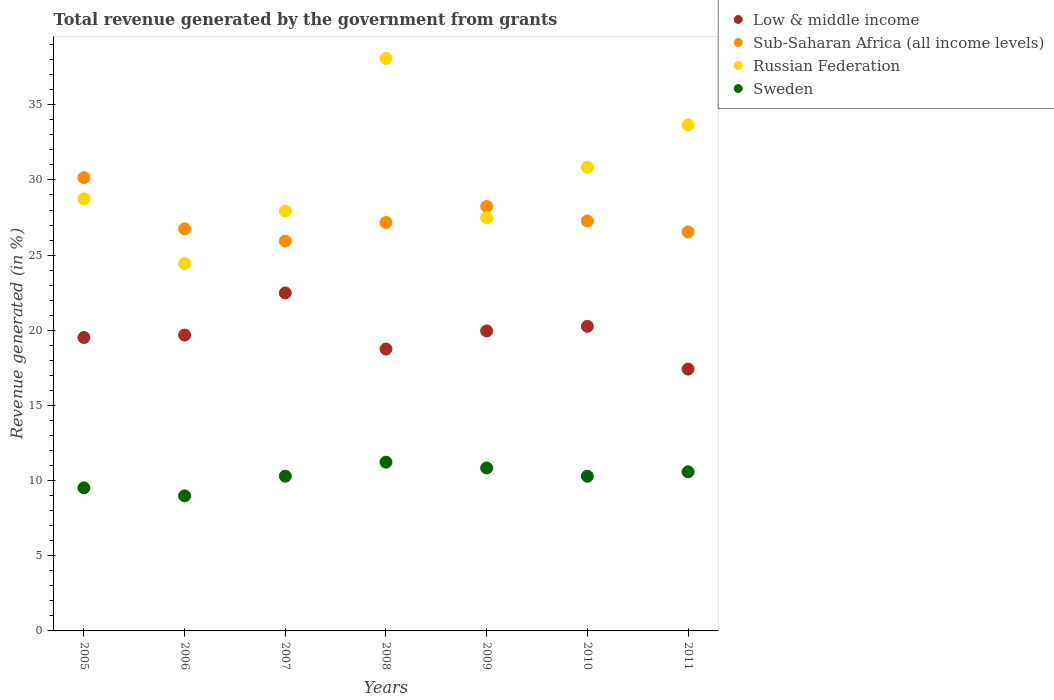How many different coloured dotlines are there?
Your answer should be compact. 4. Is the number of dotlines equal to the number of legend labels?
Your response must be concise. Yes. What is the total revenue generated in Sub-Saharan Africa (all income levels) in 2010?
Your answer should be compact. 27.27. Across all years, what is the maximum total revenue generated in Russian Federation?
Your answer should be compact. 38.08. Across all years, what is the minimum total revenue generated in Sweden?
Give a very brief answer. 8.99. In which year was the total revenue generated in Sweden maximum?
Offer a terse response. 2008. What is the total total revenue generated in Sweden in the graph?
Your answer should be very brief. 71.74. What is the difference between the total revenue generated in Sub-Saharan Africa (all income levels) in 2006 and that in 2007?
Ensure brevity in your answer.  0.81. What is the difference between the total revenue generated in Russian Federation in 2006 and the total revenue generated in Sub-Saharan Africa (all income levels) in 2005?
Provide a short and direct response. -5.71. What is the average total revenue generated in Sub-Saharan Africa (all income levels) per year?
Keep it short and to the point. 27.44. In the year 2009, what is the difference between the total revenue generated in Low & middle income and total revenue generated in Sub-Saharan Africa (all income levels)?
Offer a very short reply. -8.28. What is the ratio of the total revenue generated in Russian Federation in 2008 to that in 2010?
Offer a terse response. 1.23. What is the difference between the highest and the second highest total revenue generated in Sub-Saharan Africa (all income levels)?
Ensure brevity in your answer.  1.91. What is the difference between the highest and the lowest total revenue generated in Sweden?
Offer a terse response. 2.24. Is the total revenue generated in Sweden strictly greater than the total revenue generated in Low & middle income over the years?
Your response must be concise. No. How many dotlines are there?
Make the answer very short. 4. How many years are there in the graph?
Your answer should be very brief. 7. What is the difference between two consecutive major ticks on the Y-axis?
Your answer should be very brief. 5. Does the graph contain any zero values?
Ensure brevity in your answer.  No. How are the legend labels stacked?
Offer a very short reply. Vertical. What is the title of the graph?
Provide a short and direct response. Total revenue generated by the government from grants. What is the label or title of the X-axis?
Your response must be concise. Years. What is the label or title of the Y-axis?
Make the answer very short. Revenue generated (in %). What is the Revenue generated (in %) in Low & middle income in 2005?
Make the answer very short. 19.52. What is the Revenue generated (in %) of Sub-Saharan Africa (all income levels) in 2005?
Give a very brief answer. 30.15. What is the Revenue generated (in %) of Russian Federation in 2005?
Provide a short and direct response. 28.74. What is the Revenue generated (in %) in Sweden in 2005?
Ensure brevity in your answer.  9.52. What is the Revenue generated (in %) of Low & middle income in 2006?
Make the answer very short. 19.68. What is the Revenue generated (in %) in Sub-Saharan Africa (all income levels) in 2006?
Your answer should be very brief. 26.75. What is the Revenue generated (in %) of Russian Federation in 2006?
Give a very brief answer. 24.44. What is the Revenue generated (in %) in Sweden in 2006?
Provide a short and direct response. 8.99. What is the Revenue generated (in %) of Low & middle income in 2007?
Keep it short and to the point. 22.48. What is the Revenue generated (in %) in Sub-Saharan Africa (all income levels) in 2007?
Provide a short and direct response. 25.94. What is the Revenue generated (in %) in Russian Federation in 2007?
Your response must be concise. 27.93. What is the Revenue generated (in %) in Sweden in 2007?
Provide a short and direct response. 10.29. What is the Revenue generated (in %) in Low & middle income in 2008?
Ensure brevity in your answer.  18.75. What is the Revenue generated (in %) in Sub-Saharan Africa (all income levels) in 2008?
Your answer should be compact. 27.17. What is the Revenue generated (in %) in Russian Federation in 2008?
Offer a very short reply. 38.08. What is the Revenue generated (in %) in Sweden in 2008?
Provide a short and direct response. 11.23. What is the Revenue generated (in %) of Low & middle income in 2009?
Ensure brevity in your answer.  19.96. What is the Revenue generated (in %) in Sub-Saharan Africa (all income levels) in 2009?
Provide a succinct answer. 28.24. What is the Revenue generated (in %) of Russian Federation in 2009?
Ensure brevity in your answer.  27.48. What is the Revenue generated (in %) in Sweden in 2009?
Ensure brevity in your answer.  10.84. What is the Revenue generated (in %) in Low & middle income in 2010?
Your response must be concise. 20.26. What is the Revenue generated (in %) of Sub-Saharan Africa (all income levels) in 2010?
Provide a short and direct response. 27.27. What is the Revenue generated (in %) in Russian Federation in 2010?
Give a very brief answer. 30.84. What is the Revenue generated (in %) in Sweden in 2010?
Ensure brevity in your answer.  10.29. What is the Revenue generated (in %) in Low & middle income in 2011?
Your response must be concise. 17.42. What is the Revenue generated (in %) in Sub-Saharan Africa (all income levels) in 2011?
Give a very brief answer. 26.54. What is the Revenue generated (in %) in Russian Federation in 2011?
Offer a terse response. 33.66. What is the Revenue generated (in %) of Sweden in 2011?
Provide a short and direct response. 10.59. Across all years, what is the maximum Revenue generated (in %) in Low & middle income?
Offer a terse response. 22.48. Across all years, what is the maximum Revenue generated (in %) in Sub-Saharan Africa (all income levels)?
Provide a succinct answer. 30.15. Across all years, what is the maximum Revenue generated (in %) in Russian Federation?
Your answer should be very brief. 38.08. Across all years, what is the maximum Revenue generated (in %) in Sweden?
Offer a terse response. 11.23. Across all years, what is the minimum Revenue generated (in %) in Low & middle income?
Ensure brevity in your answer.  17.42. Across all years, what is the minimum Revenue generated (in %) of Sub-Saharan Africa (all income levels)?
Give a very brief answer. 25.94. Across all years, what is the minimum Revenue generated (in %) of Russian Federation?
Make the answer very short. 24.44. Across all years, what is the minimum Revenue generated (in %) in Sweden?
Offer a very short reply. 8.99. What is the total Revenue generated (in %) of Low & middle income in the graph?
Your response must be concise. 138.07. What is the total Revenue generated (in %) in Sub-Saharan Africa (all income levels) in the graph?
Provide a succinct answer. 192.06. What is the total Revenue generated (in %) in Russian Federation in the graph?
Offer a terse response. 211.19. What is the total Revenue generated (in %) of Sweden in the graph?
Make the answer very short. 71.74. What is the difference between the Revenue generated (in %) in Low & middle income in 2005 and that in 2006?
Your answer should be very brief. -0.16. What is the difference between the Revenue generated (in %) of Sub-Saharan Africa (all income levels) in 2005 and that in 2006?
Your answer should be very brief. 3.4. What is the difference between the Revenue generated (in %) in Russian Federation in 2005 and that in 2006?
Provide a succinct answer. 4.3. What is the difference between the Revenue generated (in %) in Sweden in 2005 and that in 2006?
Your response must be concise. 0.53. What is the difference between the Revenue generated (in %) in Low & middle income in 2005 and that in 2007?
Keep it short and to the point. -2.97. What is the difference between the Revenue generated (in %) of Sub-Saharan Africa (all income levels) in 2005 and that in 2007?
Your answer should be very brief. 4.22. What is the difference between the Revenue generated (in %) in Russian Federation in 2005 and that in 2007?
Ensure brevity in your answer.  0.82. What is the difference between the Revenue generated (in %) in Sweden in 2005 and that in 2007?
Provide a short and direct response. -0.78. What is the difference between the Revenue generated (in %) of Low & middle income in 2005 and that in 2008?
Ensure brevity in your answer.  0.77. What is the difference between the Revenue generated (in %) in Sub-Saharan Africa (all income levels) in 2005 and that in 2008?
Your answer should be compact. 2.98. What is the difference between the Revenue generated (in %) of Russian Federation in 2005 and that in 2008?
Offer a terse response. -9.34. What is the difference between the Revenue generated (in %) of Sweden in 2005 and that in 2008?
Provide a succinct answer. -1.71. What is the difference between the Revenue generated (in %) of Low & middle income in 2005 and that in 2009?
Offer a terse response. -0.44. What is the difference between the Revenue generated (in %) in Sub-Saharan Africa (all income levels) in 2005 and that in 2009?
Provide a succinct answer. 1.91. What is the difference between the Revenue generated (in %) in Russian Federation in 2005 and that in 2009?
Your response must be concise. 1.26. What is the difference between the Revenue generated (in %) in Sweden in 2005 and that in 2009?
Your response must be concise. -1.32. What is the difference between the Revenue generated (in %) in Low & middle income in 2005 and that in 2010?
Give a very brief answer. -0.74. What is the difference between the Revenue generated (in %) in Sub-Saharan Africa (all income levels) in 2005 and that in 2010?
Your response must be concise. 2.88. What is the difference between the Revenue generated (in %) of Russian Federation in 2005 and that in 2010?
Provide a short and direct response. -2.1. What is the difference between the Revenue generated (in %) of Sweden in 2005 and that in 2010?
Your answer should be very brief. -0.77. What is the difference between the Revenue generated (in %) in Low & middle income in 2005 and that in 2011?
Offer a terse response. 2.1. What is the difference between the Revenue generated (in %) in Sub-Saharan Africa (all income levels) in 2005 and that in 2011?
Your answer should be very brief. 3.61. What is the difference between the Revenue generated (in %) of Russian Federation in 2005 and that in 2011?
Make the answer very short. -4.92. What is the difference between the Revenue generated (in %) of Sweden in 2005 and that in 2011?
Give a very brief answer. -1.07. What is the difference between the Revenue generated (in %) in Low & middle income in 2006 and that in 2007?
Keep it short and to the point. -2.8. What is the difference between the Revenue generated (in %) of Sub-Saharan Africa (all income levels) in 2006 and that in 2007?
Provide a succinct answer. 0.81. What is the difference between the Revenue generated (in %) of Russian Federation in 2006 and that in 2007?
Make the answer very short. -3.49. What is the difference between the Revenue generated (in %) in Sweden in 2006 and that in 2007?
Your response must be concise. -1.31. What is the difference between the Revenue generated (in %) of Low & middle income in 2006 and that in 2008?
Offer a very short reply. 0.93. What is the difference between the Revenue generated (in %) in Sub-Saharan Africa (all income levels) in 2006 and that in 2008?
Your response must be concise. -0.42. What is the difference between the Revenue generated (in %) of Russian Federation in 2006 and that in 2008?
Offer a terse response. -13.64. What is the difference between the Revenue generated (in %) in Sweden in 2006 and that in 2008?
Ensure brevity in your answer.  -2.24. What is the difference between the Revenue generated (in %) in Low & middle income in 2006 and that in 2009?
Offer a very short reply. -0.28. What is the difference between the Revenue generated (in %) in Sub-Saharan Africa (all income levels) in 2006 and that in 2009?
Keep it short and to the point. -1.49. What is the difference between the Revenue generated (in %) of Russian Federation in 2006 and that in 2009?
Provide a succinct answer. -3.04. What is the difference between the Revenue generated (in %) in Sweden in 2006 and that in 2009?
Keep it short and to the point. -1.85. What is the difference between the Revenue generated (in %) in Low & middle income in 2006 and that in 2010?
Ensure brevity in your answer.  -0.58. What is the difference between the Revenue generated (in %) in Sub-Saharan Africa (all income levels) in 2006 and that in 2010?
Offer a very short reply. -0.52. What is the difference between the Revenue generated (in %) of Russian Federation in 2006 and that in 2010?
Your response must be concise. -6.4. What is the difference between the Revenue generated (in %) of Sweden in 2006 and that in 2010?
Ensure brevity in your answer.  -1.31. What is the difference between the Revenue generated (in %) of Low & middle income in 2006 and that in 2011?
Offer a very short reply. 2.26. What is the difference between the Revenue generated (in %) of Sub-Saharan Africa (all income levels) in 2006 and that in 2011?
Give a very brief answer. 0.2. What is the difference between the Revenue generated (in %) of Russian Federation in 2006 and that in 2011?
Ensure brevity in your answer.  -9.22. What is the difference between the Revenue generated (in %) of Sweden in 2006 and that in 2011?
Make the answer very short. -1.6. What is the difference between the Revenue generated (in %) in Low & middle income in 2007 and that in 2008?
Your response must be concise. 3.73. What is the difference between the Revenue generated (in %) of Sub-Saharan Africa (all income levels) in 2007 and that in 2008?
Ensure brevity in your answer.  -1.23. What is the difference between the Revenue generated (in %) in Russian Federation in 2007 and that in 2008?
Your response must be concise. -10.16. What is the difference between the Revenue generated (in %) of Sweden in 2007 and that in 2008?
Your answer should be very brief. -0.93. What is the difference between the Revenue generated (in %) in Low & middle income in 2007 and that in 2009?
Your response must be concise. 2.53. What is the difference between the Revenue generated (in %) in Sub-Saharan Africa (all income levels) in 2007 and that in 2009?
Offer a very short reply. -2.3. What is the difference between the Revenue generated (in %) in Russian Federation in 2007 and that in 2009?
Make the answer very short. 0.44. What is the difference between the Revenue generated (in %) in Sweden in 2007 and that in 2009?
Make the answer very short. -0.55. What is the difference between the Revenue generated (in %) in Low & middle income in 2007 and that in 2010?
Provide a succinct answer. 2.22. What is the difference between the Revenue generated (in %) of Sub-Saharan Africa (all income levels) in 2007 and that in 2010?
Your answer should be compact. -1.33. What is the difference between the Revenue generated (in %) in Russian Federation in 2007 and that in 2010?
Make the answer very short. -2.92. What is the difference between the Revenue generated (in %) of Sweden in 2007 and that in 2010?
Keep it short and to the point. 0. What is the difference between the Revenue generated (in %) of Low & middle income in 2007 and that in 2011?
Your answer should be very brief. 5.07. What is the difference between the Revenue generated (in %) of Sub-Saharan Africa (all income levels) in 2007 and that in 2011?
Your answer should be very brief. -0.61. What is the difference between the Revenue generated (in %) of Russian Federation in 2007 and that in 2011?
Keep it short and to the point. -5.73. What is the difference between the Revenue generated (in %) of Sweden in 2007 and that in 2011?
Give a very brief answer. -0.29. What is the difference between the Revenue generated (in %) in Low & middle income in 2008 and that in 2009?
Offer a very short reply. -1.2. What is the difference between the Revenue generated (in %) of Sub-Saharan Africa (all income levels) in 2008 and that in 2009?
Your answer should be very brief. -1.07. What is the difference between the Revenue generated (in %) of Russian Federation in 2008 and that in 2009?
Your response must be concise. 10.6. What is the difference between the Revenue generated (in %) in Sweden in 2008 and that in 2009?
Make the answer very short. 0.39. What is the difference between the Revenue generated (in %) in Low & middle income in 2008 and that in 2010?
Keep it short and to the point. -1.51. What is the difference between the Revenue generated (in %) of Sub-Saharan Africa (all income levels) in 2008 and that in 2010?
Offer a terse response. -0.1. What is the difference between the Revenue generated (in %) of Russian Federation in 2008 and that in 2010?
Your response must be concise. 7.24. What is the difference between the Revenue generated (in %) of Sweden in 2008 and that in 2010?
Your answer should be very brief. 0.94. What is the difference between the Revenue generated (in %) in Low & middle income in 2008 and that in 2011?
Your answer should be very brief. 1.33. What is the difference between the Revenue generated (in %) of Sub-Saharan Africa (all income levels) in 2008 and that in 2011?
Your answer should be compact. 0.62. What is the difference between the Revenue generated (in %) in Russian Federation in 2008 and that in 2011?
Your response must be concise. 4.42. What is the difference between the Revenue generated (in %) of Sweden in 2008 and that in 2011?
Give a very brief answer. 0.64. What is the difference between the Revenue generated (in %) in Low & middle income in 2009 and that in 2010?
Your answer should be very brief. -0.31. What is the difference between the Revenue generated (in %) in Sub-Saharan Africa (all income levels) in 2009 and that in 2010?
Your response must be concise. 0.97. What is the difference between the Revenue generated (in %) in Russian Federation in 2009 and that in 2010?
Your answer should be compact. -3.36. What is the difference between the Revenue generated (in %) of Sweden in 2009 and that in 2010?
Ensure brevity in your answer.  0.55. What is the difference between the Revenue generated (in %) in Low & middle income in 2009 and that in 2011?
Offer a terse response. 2.54. What is the difference between the Revenue generated (in %) in Sub-Saharan Africa (all income levels) in 2009 and that in 2011?
Ensure brevity in your answer.  1.69. What is the difference between the Revenue generated (in %) in Russian Federation in 2009 and that in 2011?
Offer a terse response. -6.18. What is the difference between the Revenue generated (in %) in Sweden in 2009 and that in 2011?
Keep it short and to the point. 0.26. What is the difference between the Revenue generated (in %) in Low & middle income in 2010 and that in 2011?
Offer a very short reply. 2.84. What is the difference between the Revenue generated (in %) in Sub-Saharan Africa (all income levels) in 2010 and that in 2011?
Provide a short and direct response. 0.72. What is the difference between the Revenue generated (in %) of Russian Federation in 2010 and that in 2011?
Provide a succinct answer. -2.82. What is the difference between the Revenue generated (in %) in Sweden in 2010 and that in 2011?
Give a very brief answer. -0.29. What is the difference between the Revenue generated (in %) of Low & middle income in 2005 and the Revenue generated (in %) of Sub-Saharan Africa (all income levels) in 2006?
Provide a short and direct response. -7.23. What is the difference between the Revenue generated (in %) of Low & middle income in 2005 and the Revenue generated (in %) of Russian Federation in 2006?
Your answer should be compact. -4.92. What is the difference between the Revenue generated (in %) in Low & middle income in 2005 and the Revenue generated (in %) in Sweden in 2006?
Offer a terse response. 10.53. What is the difference between the Revenue generated (in %) of Sub-Saharan Africa (all income levels) in 2005 and the Revenue generated (in %) of Russian Federation in 2006?
Provide a succinct answer. 5.71. What is the difference between the Revenue generated (in %) of Sub-Saharan Africa (all income levels) in 2005 and the Revenue generated (in %) of Sweden in 2006?
Offer a very short reply. 21.17. What is the difference between the Revenue generated (in %) of Russian Federation in 2005 and the Revenue generated (in %) of Sweden in 2006?
Give a very brief answer. 19.76. What is the difference between the Revenue generated (in %) in Low & middle income in 2005 and the Revenue generated (in %) in Sub-Saharan Africa (all income levels) in 2007?
Ensure brevity in your answer.  -6.42. What is the difference between the Revenue generated (in %) in Low & middle income in 2005 and the Revenue generated (in %) in Russian Federation in 2007?
Offer a terse response. -8.41. What is the difference between the Revenue generated (in %) in Low & middle income in 2005 and the Revenue generated (in %) in Sweden in 2007?
Offer a very short reply. 9.22. What is the difference between the Revenue generated (in %) of Sub-Saharan Africa (all income levels) in 2005 and the Revenue generated (in %) of Russian Federation in 2007?
Give a very brief answer. 2.22. What is the difference between the Revenue generated (in %) in Sub-Saharan Africa (all income levels) in 2005 and the Revenue generated (in %) in Sweden in 2007?
Keep it short and to the point. 19.86. What is the difference between the Revenue generated (in %) in Russian Federation in 2005 and the Revenue generated (in %) in Sweden in 2007?
Offer a terse response. 18.45. What is the difference between the Revenue generated (in %) in Low & middle income in 2005 and the Revenue generated (in %) in Sub-Saharan Africa (all income levels) in 2008?
Provide a short and direct response. -7.65. What is the difference between the Revenue generated (in %) of Low & middle income in 2005 and the Revenue generated (in %) of Russian Federation in 2008?
Provide a short and direct response. -18.57. What is the difference between the Revenue generated (in %) in Low & middle income in 2005 and the Revenue generated (in %) in Sweden in 2008?
Offer a very short reply. 8.29. What is the difference between the Revenue generated (in %) in Sub-Saharan Africa (all income levels) in 2005 and the Revenue generated (in %) in Russian Federation in 2008?
Keep it short and to the point. -7.93. What is the difference between the Revenue generated (in %) of Sub-Saharan Africa (all income levels) in 2005 and the Revenue generated (in %) of Sweden in 2008?
Your answer should be compact. 18.92. What is the difference between the Revenue generated (in %) in Russian Federation in 2005 and the Revenue generated (in %) in Sweden in 2008?
Offer a very short reply. 17.52. What is the difference between the Revenue generated (in %) of Low & middle income in 2005 and the Revenue generated (in %) of Sub-Saharan Africa (all income levels) in 2009?
Provide a short and direct response. -8.72. What is the difference between the Revenue generated (in %) of Low & middle income in 2005 and the Revenue generated (in %) of Russian Federation in 2009?
Keep it short and to the point. -7.97. What is the difference between the Revenue generated (in %) of Low & middle income in 2005 and the Revenue generated (in %) of Sweden in 2009?
Keep it short and to the point. 8.68. What is the difference between the Revenue generated (in %) in Sub-Saharan Africa (all income levels) in 2005 and the Revenue generated (in %) in Russian Federation in 2009?
Give a very brief answer. 2.67. What is the difference between the Revenue generated (in %) in Sub-Saharan Africa (all income levels) in 2005 and the Revenue generated (in %) in Sweden in 2009?
Make the answer very short. 19.31. What is the difference between the Revenue generated (in %) in Russian Federation in 2005 and the Revenue generated (in %) in Sweden in 2009?
Make the answer very short. 17.9. What is the difference between the Revenue generated (in %) in Low & middle income in 2005 and the Revenue generated (in %) in Sub-Saharan Africa (all income levels) in 2010?
Provide a short and direct response. -7.75. What is the difference between the Revenue generated (in %) in Low & middle income in 2005 and the Revenue generated (in %) in Russian Federation in 2010?
Give a very brief answer. -11.33. What is the difference between the Revenue generated (in %) of Low & middle income in 2005 and the Revenue generated (in %) of Sweden in 2010?
Provide a short and direct response. 9.23. What is the difference between the Revenue generated (in %) in Sub-Saharan Africa (all income levels) in 2005 and the Revenue generated (in %) in Russian Federation in 2010?
Your answer should be very brief. -0.69. What is the difference between the Revenue generated (in %) of Sub-Saharan Africa (all income levels) in 2005 and the Revenue generated (in %) of Sweden in 2010?
Keep it short and to the point. 19.86. What is the difference between the Revenue generated (in %) in Russian Federation in 2005 and the Revenue generated (in %) in Sweden in 2010?
Your response must be concise. 18.45. What is the difference between the Revenue generated (in %) in Low & middle income in 2005 and the Revenue generated (in %) in Sub-Saharan Africa (all income levels) in 2011?
Give a very brief answer. -7.03. What is the difference between the Revenue generated (in %) in Low & middle income in 2005 and the Revenue generated (in %) in Russian Federation in 2011?
Your answer should be compact. -14.14. What is the difference between the Revenue generated (in %) in Low & middle income in 2005 and the Revenue generated (in %) in Sweden in 2011?
Your answer should be very brief. 8.93. What is the difference between the Revenue generated (in %) of Sub-Saharan Africa (all income levels) in 2005 and the Revenue generated (in %) of Russian Federation in 2011?
Give a very brief answer. -3.51. What is the difference between the Revenue generated (in %) in Sub-Saharan Africa (all income levels) in 2005 and the Revenue generated (in %) in Sweden in 2011?
Your response must be concise. 19.57. What is the difference between the Revenue generated (in %) in Russian Federation in 2005 and the Revenue generated (in %) in Sweden in 2011?
Offer a very short reply. 18.16. What is the difference between the Revenue generated (in %) of Low & middle income in 2006 and the Revenue generated (in %) of Sub-Saharan Africa (all income levels) in 2007?
Offer a terse response. -6.25. What is the difference between the Revenue generated (in %) in Low & middle income in 2006 and the Revenue generated (in %) in Russian Federation in 2007?
Make the answer very short. -8.25. What is the difference between the Revenue generated (in %) of Low & middle income in 2006 and the Revenue generated (in %) of Sweden in 2007?
Your answer should be compact. 9.39. What is the difference between the Revenue generated (in %) in Sub-Saharan Africa (all income levels) in 2006 and the Revenue generated (in %) in Russian Federation in 2007?
Your response must be concise. -1.18. What is the difference between the Revenue generated (in %) in Sub-Saharan Africa (all income levels) in 2006 and the Revenue generated (in %) in Sweden in 2007?
Keep it short and to the point. 16.45. What is the difference between the Revenue generated (in %) in Russian Federation in 2006 and the Revenue generated (in %) in Sweden in 2007?
Provide a succinct answer. 14.15. What is the difference between the Revenue generated (in %) in Low & middle income in 2006 and the Revenue generated (in %) in Sub-Saharan Africa (all income levels) in 2008?
Ensure brevity in your answer.  -7.49. What is the difference between the Revenue generated (in %) in Low & middle income in 2006 and the Revenue generated (in %) in Russian Federation in 2008?
Ensure brevity in your answer.  -18.4. What is the difference between the Revenue generated (in %) in Low & middle income in 2006 and the Revenue generated (in %) in Sweden in 2008?
Keep it short and to the point. 8.45. What is the difference between the Revenue generated (in %) in Sub-Saharan Africa (all income levels) in 2006 and the Revenue generated (in %) in Russian Federation in 2008?
Your answer should be very brief. -11.34. What is the difference between the Revenue generated (in %) in Sub-Saharan Africa (all income levels) in 2006 and the Revenue generated (in %) in Sweden in 2008?
Your response must be concise. 15.52. What is the difference between the Revenue generated (in %) in Russian Federation in 2006 and the Revenue generated (in %) in Sweden in 2008?
Offer a very short reply. 13.21. What is the difference between the Revenue generated (in %) in Low & middle income in 2006 and the Revenue generated (in %) in Sub-Saharan Africa (all income levels) in 2009?
Offer a very short reply. -8.56. What is the difference between the Revenue generated (in %) of Low & middle income in 2006 and the Revenue generated (in %) of Russian Federation in 2009?
Give a very brief answer. -7.8. What is the difference between the Revenue generated (in %) of Low & middle income in 2006 and the Revenue generated (in %) of Sweden in 2009?
Provide a short and direct response. 8.84. What is the difference between the Revenue generated (in %) of Sub-Saharan Africa (all income levels) in 2006 and the Revenue generated (in %) of Russian Federation in 2009?
Your answer should be compact. -0.74. What is the difference between the Revenue generated (in %) in Sub-Saharan Africa (all income levels) in 2006 and the Revenue generated (in %) in Sweden in 2009?
Provide a succinct answer. 15.91. What is the difference between the Revenue generated (in %) in Russian Federation in 2006 and the Revenue generated (in %) in Sweden in 2009?
Your answer should be compact. 13.6. What is the difference between the Revenue generated (in %) of Low & middle income in 2006 and the Revenue generated (in %) of Sub-Saharan Africa (all income levels) in 2010?
Ensure brevity in your answer.  -7.59. What is the difference between the Revenue generated (in %) in Low & middle income in 2006 and the Revenue generated (in %) in Russian Federation in 2010?
Your answer should be compact. -11.16. What is the difference between the Revenue generated (in %) of Low & middle income in 2006 and the Revenue generated (in %) of Sweden in 2010?
Make the answer very short. 9.39. What is the difference between the Revenue generated (in %) of Sub-Saharan Africa (all income levels) in 2006 and the Revenue generated (in %) of Russian Federation in 2010?
Ensure brevity in your answer.  -4.1. What is the difference between the Revenue generated (in %) of Sub-Saharan Africa (all income levels) in 2006 and the Revenue generated (in %) of Sweden in 2010?
Provide a short and direct response. 16.46. What is the difference between the Revenue generated (in %) of Russian Federation in 2006 and the Revenue generated (in %) of Sweden in 2010?
Your answer should be compact. 14.15. What is the difference between the Revenue generated (in %) in Low & middle income in 2006 and the Revenue generated (in %) in Sub-Saharan Africa (all income levels) in 2011?
Give a very brief answer. -6.86. What is the difference between the Revenue generated (in %) of Low & middle income in 2006 and the Revenue generated (in %) of Russian Federation in 2011?
Your answer should be very brief. -13.98. What is the difference between the Revenue generated (in %) in Low & middle income in 2006 and the Revenue generated (in %) in Sweden in 2011?
Make the answer very short. 9.1. What is the difference between the Revenue generated (in %) of Sub-Saharan Africa (all income levels) in 2006 and the Revenue generated (in %) of Russian Federation in 2011?
Provide a short and direct response. -6.92. What is the difference between the Revenue generated (in %) of Sub-Saharan Africa (all income levels) in 2006 and the Revenue generated (in %) of Sweden in 2011?
Provide a short and direct response. 16.16. What is the difference between the Revenue generated (in %) of Russian Federation in 2006 and the Revenue generated (in %) of Sweden in 2011?
Provide a short and direct response. 13.86. What is the difference between the Revenue generated (in %) in Low & middle income in 2007 and the Revenue generated (in %) in Sub-Saharan Africa (all income levels) in 2008?
Offer a very short reply. -4.68. What is the difference between the Revenue generated (in %) of Low & middle income in 2007 and the Revenue generated (in %) of Russian Federation in 2008?
Your response must be concise. -15.6. What is the difference between the Revenue generated (in %) of Low & middle income in 2007 and the Revenue generated (in %) of Sweden in 2008?
Your response must be concise. 11.26. What is the difference between the Revenue generated (in %) in Sub-Saharan Africa (all income levels) in 2007 and the Revenue generated (in %) in Russian Federation in 2008?
Provide a short and direct response. -12.15. What is the difference between the Revenue generated (in %) of Sub-Saharan Africa (all income levels) in 2007 and the Revenue generated (in %) of Sweden in 2008?
Your answer should be compact. 14.71. What is the difference between the Revenue generated (in %) in Russian Federation in 2007 and the Revenue generated (in %) in Sweden in 2008?
Keep it short and to the point. 16.7. What is the difference between the Revenue generated (in %) of Low & middle income in 2007 and the Revenue generated (in %) of Sub-Saharan Africa (all income levels) in 2009?
Keep it short and to the point. -5.75. What is the difference between the Revenue generated (in %) of Low & middle income in 2007 and the Revenue generated (in %) of Russian Federation in 2009?
Provide a short and direct response. -5. What is the difference between the Revenue generated (in %) in Low & middle income in 2007 and the Revenue generated (in %) in Sweden in 2009?
Provide a succinct answer. 11.64. What is the difference between the Revenue generated (in %) in Sub-Saharan Africa (all income levels) in 2007 and the Revenue generated (in %) in Russian Federation in 2009?
Offer a terse response. -1.55. What is the difference between the Revenue generated (in %) of Sub-Saharan Africa (all income levels) in 2007 and the Revenue generated (in %) of Sweden in 2009?
Ensure brevity in your answer.  15.1. What is the difference between the Revenue generated (in %) in Russian Federation in 2007 and the Revenue generated (in %) in Sweden in 2009?
Provide a short and direct response. 17.09. What is the difference between the Revenue generated (in %) in Low & middle income in 2007 and the Revenue generated (in %) in Sub-Saharan Africa (all income levels) in 2010?
Provide a short and direct response. -4.78. What is the difference between the Revenue generated (in %) of Low & middle income in 2007 and the Revenue generated (in %) of Russian Federation in 2010?
Provide a short and direct response. -8.36. What is the difference between the Revenue generated (in %) of Low & middle income in 2007 and the Revenue generated (in %) of Sweden in 2010?
Your answer should be compact. 12.19. What is the difference between the Revenue generated (in %) in Sub-Saharan Africa (all income levels) in 2007 and the Revenue generated (in %) in Russian Federation in 2010?
Provide a short and direct response. -4.91. What is the difference between the Revenue generated (in %) in Sub-Saharan Africa (all income levels) in 2007 and the Revenue generated (in %) in Sweden in 2010?
Offer a terse response. 15.64. What is the difference between the Revenue generated (in %) of Russian Federation in 2007 and the Revenue generated (in %) of Sweden in 2010?
Your response must be concise. 17.64. What is the difference between the Revenue generated (in %) of Low & middle income in 2007 and the Revenue generated (in %) of Sub-Saharan Africa (all income levels) in 2011?
Make the answer very short. -4.06. What is the difference between the Revenue generated (in %) of Low & middle income in 2007 and the Revenue generated (in %) of Russian Federation in 2011?
Keep it short and to the point. -11.18. What is the difference between the Revenue generated (in %) of Low & middle income in 2007 and the Revenue generated (in %) of Sweden in 2011?
Your response must be concise. 11.9. What is the difference between the Revenue generated (in %) in Sub-Saharan Africa (all income levels) in 2007 and the Revenue generated (in %) in Russian Federation in 2011?
Offer a terse response. -7.73. What is the difference between the Revenue generated (in %) in Sub-Saharan Africa (all income levels) in 2007 and the Revenue generated (in %) in Sweden in 2011?
Your answer should be compact. 15.35. What is the difference between the Revenue generated (in %) of Russian Federation in 2007 and the Revenue generated (in %) of Sweden in 2011?
Your answer should be very brief. 17.34. What is the difference between the Revenue generated (in %) in Low & middle income in 2008 and the Revenue generated (in %) in Sub-Saharan Africa (all income levels) in 2009?
Offer a very short reply. -9.49. What is the difference between the Revenue generated (in %) of Low & middle income in 2008 and the Revenue generated (in %) of Russian Federation in 2009?
Your answer should be compact. -8.73. What is the difference between the Revenue generated (in %) of Low & middle income in 2008 and the Revenue generated (in %) of Sweden in 2009?
Provide a succinct answer. 7.91. What is the difference between the Revenue generated (in %) of Sub-Saharan Africa (all income levels) in 2008 and the Revenue generated (in %) of Russian Federation in 2009?
Ensure brevity in your answer.  -0.32. What is the difference between the Revenue generated (in %) in Sub-Saharan Africa (all income levels) in 2008 and the Revenue generated (in %) in Sweden in 2009?
Your answer should be very brief. 16.33. What is the difference between the Revenue generated (in %) in Russian Federation in 2008 and the Revenue generated (in %) in Sweden in 2009?
Keep it short and to the point. 27.24. What is the difference between the Revenue generated (in %) of Low & middle income in 2008 and the Revenue generated (in %) of Sub-Saharan Africa (all income levels) in 2010?
Make the answer very short. -8.52. What is the difference between the Revenue generated (in %) in Low & middle income in 2008 and the Revenue generated (in %) in Russian Federation in 2010?
Offer a terse response. -12.09. What is the difference between the Revenue generated (in %) of Low & middle income in 2008 and the Revenue generated (in %) of Sweden in 2010?
Offer a very short reply. 8.46. What is the difference between the Revenue generated (in %) in Sub-Saharan Africa (all income levels) in 2008 and the Revenue generated (in %) in Russian Federation in 2010?
Provide a short and direct response. -3.68. What is the difference between the Revenue generated (in %) in Sub-Saharan Africa (all income levels) in 2008 and the Revenue generated (in %) in Sweden in 2010?
Keep it short and to the point. 16.88. What is the difference between the Revenue generated (in %) in Russian Federation in 2008 and the Revenue generated (in %) in Sweden in 2010?
Give a very brief answer. 27.79. What is the difference between the Revenue generated (in %) in Low & middle income in 2008 and the Revenue generated (in %) in Sub-Saharan Africa (all income levels) in 2011?
Provide a short and direct response. -7.79. What is the difference between the Revenue generated (in %) in Low & middle income in 2008 and the Revenue generated (in %) in Russian Federation in 2011?
Your response must be concise. -14.91. What is the difference between the Revenue generated (in %) of Low & middle income in 2008 and the Revenue generated (in %) of Sweden in 2011?
Your answer should be compact. 8.17. What is the difference between the Revenue generated (in %) of Sub-Saharan Africa (all income levels) in 2008 and the Revenue generated (in %) of Russian Federation in 2011?
Make the answer very short. -6.49. What is the difference between the Revenue generated (in %) in Sub-Saharan Africa (all income levels) in 2008 and the Revenue generated (in %) in Sweden in 2011?
Your answer should be compact. 16.58. What is the difference between the Revenue generated (in %) of Russian Federation in 2008 and the Revenue generated (in %) of Sweden in 2011?
Offer a very short reply. 27.5. What is the difference between the Revenue generated (in %) in Low & middle income in 2009 and the Revenue generated (in %) in Sub-Saharan Africa (all income levels) in 2010?
Your response must be concise. -7.31. What is the difference between the Revenue generated (in %) in Low & middle income in 2009 and the Revenue generated (in %) in Russian Federation in 2010?
Give a very brief answer. -10.89. What is the difference between the Revenue generated (in %) in Low & middle income in 2009 and the Revenue generated (in %) in Sweden in 2010?
Your response must be concise. 9.67. What is the difference between the Revenue generated (in %) of Sub-Saharan Africa (all income levels) in 2009 and the Revenue generated (in %) of Russian Federation in 2010?
Give a very brief answer. -2.61. What is the difference between the Revenue generated (in %) in Sub-Saharan Africa (all income levels) in 2009 and the Revenue generated (in %) in Sweden in 2010?
Your answer should be very brief. 17.95. What is the difference between the Revenue generated (in %) of Russian Federation in 2009 and the Revenue generated (in %) of Sweden in 2010?
Provide a short and direct response. 17.19. What is the difference between the Revenue generated (in %) of Low & middle income in 2009 and the Revenue generated (in %) of Sub-Saharan Africa (all income levels) in 2011?
Ensure brevity in your answer.  -6.59. What is the difference between the Revenue generated (in %) of Low & middle income in 2009 and the Revenue generated (in %) of Russian Federation in 2011?
Make the answer very short. -13.71. What is the difference between the Revenue generated (in %) of Low & middle income in 2009 and the Revenue generated (in %) of Sweden in 2011?
Offer a terse response. 9.37. What is the difference between the Revenue generated (in %) of Sub-Saharan Africa (all income levels) in 2009 and the Revenue generated (in %) of Russian Federation in 2011?
Offer a terse response. -5.42. What is the difference between the Revenue generated (in %) of Sub-Saharan Africa (all income levels) in 2009 and the Revenue generated (in %) of Sweden in 2011?
Your answer should be very brief. 17.65. What is the difference between the Revenue generated (in %) of Russian Federation in 2009 and the Revenue generated (in %) of Sweden in 2011?
Your answer should be compact. 16.9. What is the difference between the Revenue generated (in %) in Low & middle income in 2010 and the Revenue generated (in %) in Sub-Saharan Africa (all income levels) in 2011?
Ensure brevity in your answer.  -6.28. What is the difference between the Revenue generated (in %) of Low & middle income in 2010 and the Revenue generated (in %) of Russian Federation in 2011?
Provide a succinct answer. -13.4. What is the difference between the Revenue generated (in %) in Low & middle income in 2010 and the Revenue generated (in %) in Sweden in 2011?
Offer a terse response. 9.68. What is the difference between the Revenue generated (in %) in Sub-Saharan Africa (all income levels) in 2010 and the Revenue generated (in %) in Russian Federation in 2011?
Give a very brief answer. -6.39. What is the difference between the Revenue generated (in %) of Sub-Saharan Africa (all income levels) in 2010 and the Revenue generated (in %) of Sweden in 2011?
Offer a very short reply. 16.68. What is the difference between the Revenue generated (in %) of Russian Federation in 2010 and the Revenue generated (in %) of Sweden in 2011?
Make the answer very short. 20.26. What is the average Revenue generated (in %) in Low & middle income per year?
Keep it short and to the point. 19.72. What is the average Revenue generated (in %) in Sub-Saharan Africa (all income levels) per year?
Offer a terse response. 27.44. What is the average Revenue generated (in %) in Russian Federation per year?
Provide a succinct answer. 30.17. What is the average Revenue generated (in %) of Sweden per year?
Offer a very short reply. 10.25. In the year 2005, what is the difference between the Revenue generated (in %) in Low & middle income and Revenue generated (in %) in Sub-Saharan Africa (all income levels)?
Offer a terse response. -10.63. In the year 2005, what is the difference between the Revenue generated (in %) in Low & middle income and Revenue generated (in %) in Russian Federation?
Your response must be concise. -9.23. In the year 2005, what is the difference between the Revenue generated (in %) of Low & middle income and Revenue generated (in %) of Sweden?
Ensure brevity in your answer.  10. In the year 2005, what is the difference between the Revenue generated (in %) in Sub-Saharan Africa (all income levels) and Revenue generated (in %) in Russian Federation?
Provide a short and direct response. 1.41. In the year 2005, what is the difference between the Revenue generated (in %) of Sub-Saharan Africa (all income levels) and Revenue generated (in %) of Sweden?
Keep it short and to the point. 20.63. In the year 2005, what is the difference between the Revenue generated (in %) of Russian Federation and Revenue generated (in %) of Sweden?
Provide a succinct answer. 19.23. In the year 2006, what is the difference between the Revenue generated (in %) in Low & middle income and Revenue generated (in %) in Sub-Saharan Africa (all income levels)?
Your answer should be very brief. -7.07. In the year 2006, what is the difference between the Revenue generated (in %) of Low & middle income and Revenue generated (in %) of Russian Federation?
Provide a short and direct response. -4.76. In the year 2006, what is the difference between the Revenue generated (in %) in Low & middle income and Revenue generated (in %) in Sweden?
Provide a succinct answer. 10.69. In the year 2006, what is the difference between the Revenue generated (in %) of Sub-Saharan Africa (all income levels) and Revenue generated (in %) of Russian Federation?
Make the answer very short. 2.31. In the year 2006, what is the difference between the Revenue generated (in %) of Sub-Saharan Africa (all income levels) and Revenue generated (in %) of Sweden?
Give a very brief answer. 17.76. In the year 2006, what is the difference between the Revenue generated (in %) in Russian Federation and Revenue generated (in %) in Sweden?
Make the answer very short. 15.45. In the year 2007, what is the difference between the Revenue generated (in %) in Low & middle income and Revenue generated (in %) in Sub-Saharan Africa (all income levels)?
Make the answer very short. -3.45. In the year 2007, what is the difference between the Revenue generated (in %) of Low & middle income and Revenue generated (in %) of Russian Federation?
Your answer should be compact. -5.44. In the year 2007, what is the difference between the Revenue generated (in %) in Low & middle income and Revenue generated (in %) in Sweden?
Make the answer very short. 12.19. In the year 2007, what is the difference between the Revenue generated (in %) of Sub-Saharan Africa (all income levels) and Revenue generated (in %) of Russian Federation?
Ensure brevity in your answer.  -1.99. In the year 2007, what is the difference between the Revenue generated (in %) in Sub-Saharan Africa (all income levels) and Revenue generated (in %) in Sweden?
Ensure brevity in your answer.  15.64. In the year 2007, what is the difference between the Revenue generated (in %) in Russian Federation and Revenue generated (in %) in Sweden?
Offer a terse response. 17.63. In the year 2008, what is the difference between the Revenue generated (in %) of Low & middle income and Revenue generated (in %) of Sub-Saharan Africa (all income levels)?
Give a very brief answer. -8.42. In the year 2008, what is the difference between the Revenue generated (in %) of Low & middle income and Revenue generated (in %) of Russian Federation?
Give a very brief answer. -19.33. In the year 2008, what is the difference between the Revenue generated (in %) of Low & middle income and Revenue generated (in %) of Sweden?
Your response must be concise. 7.52. In the year 2008, what is the difference between the Revenue generated (in %) of Sub-Saharan Africa (all income levels) and Revenue generated (in %) of Russian Federation?
Your response must be concise. -10.91. In the year 2008, what is the difference between the Revenue generated (in %) in Sub-Saharan Africa (all income levels) and Revenue generated (in %) in Sweden?
Your answer should be compact. 15.94. In the year 2008, what is the difference between the Revenue generated (in %) in Russian Federation and Revenue generated (in %) in Sweden?
Ensure brevity in your answer.  26.86. In the year 2009, what is the difference between the Revenue generated (in %) in Low & middle income and Revenue generated (in %) in Sub-Saharan Africa (all income levels)?
Provide a succinct answer. -8.28. In the year 2009, what is the difference between the Revenue generated (in %) in Low & middle income and Revenue generated (in %) in Russian Federation?
Your response must be concise. -7.53. In the year 2009, what is the difference between the Revenue generated (in %) of Low & middle income and Revenue generated (in %) of Sweden?
Ensure brevity in your answer.  9.12. In the year 2009, what is the difference between the Revenue generated (in %) in Sub-Saharan Africa (all income levels) and Revenue generated (in %) in Russian Federation?
Your answer should be compact. 0.75. In the year 2009, what is the difference between the Revenue generated (in %) of Sub-Saharan Africa (all income levels) and Revenue generated (in %) of Sweden?
Make the answer very short. 17.4. In the year 2009, what is the difference between the Revenue generated (in %) in Russian Federation and Revenue generated (in %) in Sweden?
Provide a short and direct response. 16.64. In the year 2010, what is the difference between the Revenue generated (in %) of Low & middle income and Revenue generated (in %) of Sub-Saharan Africa (all income levels)?
Your answer should be compact. -7.01. In the year 2010, what is the difference between the Revenue generated (in %) in Low & middle income and Revenue generated (in %) in Russian Federation?
Give a very brief answer. -10.58. In the year 2010, what is the difference between the Revenue generated (in %) in Low & middle income and Revenue generated (in %) in Sweden?
Make the answer very short. 9.97. In the year 2010, what is the difference between the Revenue generated (in %) of Sub-Saharan Africa (all income levels) and Revenue generated (in %) of Russian Federation?
Keep it short and to the point. -3.58. In the year 2010, what is the difference between the Revenue generated (in %) of Sub-Saharan Africa (all income levels) and Revenue generated (in %) of Sweden?
Offer a terse response. 16.98. In the year 2010, what is the difference between the Revenue generated (in %) of Russian Federation and Revenue generated (in %) of Sweden?
Make the answer very short. 20.55. In the year 2011, what is the difference between the Revenue generated (in %) in Low & middle income and Revenue generated (in %) in Sub-Saharan Africa (all income levels)?
Provide a short and direct response. -9.13. In the year 2011, what is the difference between the Revenue generated (in %) in Low & middle income and Revenue generated (in %) in Russian Federation?
Ensure brevity in your answer.  -16.25. In the year 2011, what is the difference between the Revenue generated (in %) in Low & middle income and Revenue generated (in %) in Sweden?
Make the answer very short. 6.83. In the year 2011, what is the difference between the Revenue generated (in %) in Sub-Saharan Africa (all income levels) and Revenue generated (in %) in Russian Federation?
Keep it short and to the point. -7.12. In the year 2011, what is the difference between the Revenue generated (in %) of Sub-Saharan Africa (all income levels) and Revenue generated (in %) of Sweden?
Offer a terse response. 15.96. In the year 2011, what is the difference between the Revenue generated (in %) of Russian Federation and Revenue generated (in %) of Sweden?
Offer a very short reply. 23.08. What is the ratio of the Revenue generated (in %) of Sub-Saharan Africa (all income levels) in 2005 to that in 2006?
Offer a very short reply. 1.13. What is the ratio of the Revenue generated (in %) of Russian Federation in 2005 to that in 2006?
Your answer should be compact. 1.18. What is the ratio of the Revenue generated (in %) of Sweden in 2005 to that in 2006?
Keep it short and to the point. 1.06. What is the ratio of the Revenue generated (in %) of Low & middle income in 2005 to that in 2007?
Ensure brevity in your answer.  0.87. What is the ratio of the Revenue generated (in %) in Sub-Saharan Africa (all income levels) in 2005 to that in 2007?
Provide a short and direct response. 1.16. What is the ratio of the Revenue generated (in %) in Russian Federation in 2005 to that in 2007?
Your answer should be compact. 1.03. What is the ratio of the Revenue generated (in %) in Sweden in 2005 to that in 2007?
Make the answer very short. 0.92. What is the ratio of the Revenue generated (in %) of Low & middle income in 2005 to that in 2008?
Keep it short and to the point. 1.04. What is the ratio of the Revenue generated (in %) in Sub-Saharan Africa (all income levels) in 2005 to that in 2008?
Ensure brevity in your answer.  1.11. What is the ratio of the Revenue generated (in %) of Russian Federation in 2005 to that in 2008?
Provide a short and direct response. 0.75. What is the ratio of the Revenue generated (in %) of Sweden in 2005 to that in 2008?
Ensure brevity in your answer.  0.85. What is the ratio of the Revenue generated (in %) in Low & middle income in 2005 to that in 2009?
Provide a succinct answer. 0.98. What is the ratio of the Revenue generated (in %) of Sub-Saharan Africa (all income levels) in 2005 to that in 2009?
Offer a terse response. 1.07. What is the ratio of the Revenue generated (in %) of Russian Federation in 2005 to that in 2009?
Provide a short and direct response. 1.05. What is the ratio of the Revenue generated (in %) of Sweden in 2005 to that in 2009?
Keep it short and to the point. 0.88. What is the ratio of the Revenue generated (in %) of Low & middle income in 2005 to that in 2010?
Your response must be concise. 0.96. What is the ratio of the Revenue generated (in %) in Sub-Saharan Africa (all income levels) in 2005 to that in 2010?
Provide a short and direct response. 1.11. What is the ratio of the Revenue generated (in %) of Russian Federation in 2005 to that in 2010?
Your answer should be very brief. 0.93. What is the ratio of the Revenue generated (in %) in Sweden in 2005 to that in 2010?
Offer a terse response. 0.92. What is the ratio of the Revenue generated (in %) in Low & middle income in 2005 to that in 2011?
Provide a succinct answer. 1.12. What is the ratio of the Revenue generated (in %) of Sub-Saharan Africa (all income levels) in 2005 to that in 2011?
Your answer should be very brief. 1.14. What is the ratio of the Revenue generated (in %) of Russian Federation in 2005 to that in 2011?
Make the answer very short. 0.85. What is the ratio of the Revenue generated (in %) of Sweden in 2005 to that in 2011?
Keep it short and to the point. 0.9. What is the ratio of the Revenue generated (in %) of Low & middle income in 2006 to that in 2007?
Offer a very short reply. 0.88. What is the ratio of the Revenue generated (in %) in Sub-Saharan Africa (all income levels) in 2006 to that in 2007?
Your response must be concise. 1.03. What is the ratio of the Revenue generated (in %) of Russian Federation in 2006 to that in 2007?
Offer a very short reply. 0.88. What is the ratio of the Revenue generated (in %) of Sweden in 2006 to that in 2007?
Offer a terse response. 0.87. What is the ratio of the Revenue generated (in %) in Low & middle income in 2006 to that in 2008?
Ensure brevity in your answer.  1.05. What is the ratio of the Revenue generated (in %) in Sub-Saharan Africa (all income levels) in 2006 to that in 2008?
Keep it short and to the point. 0.98. What is the ratio of the Revenue generated (in %) in Russian Federation in 2006 to that in 2008?
Give a very brief answer. 0.64. What is the ratio of the Revenue generated (in %) of Sweden in 2006 to that in 2008?
Provide a short and direct response. 0.8. What is the ratio of the Revenue generated (in %) in Low & middle income in 2006 to that in 2009?
Your answer should be compact. 0.99. What is the ratio of the Revenue generated (in %) in Sub-Saharan Africa (all income levels) in 2006 to that in 2009?
Provide a short and direct response. 0.95. What is the ratio of the Revenue generated (in %) in Russian Federation in 2006 to that in 2009?
Keep it short and to the point. 0.89. What is the ratio of the Revenue generated (in %) in Sweden in 2006 to that in 2009?
Your answer should be very brief. 0.83. What is the ratio of the Revenue generated (in %) of Low & middle income in 2006 to that in 2010?
Your response must be concise. 0.97. What is the ratio of the Revenue generated (in %) of Sub-Saharan Africa (all income levels) in 2006 to that in 2010?
Give a very brief answer. 0.98. What is the ratio of the Revenue generated (in %) in Russian Federation in 2006 to that in 2010?
Ensure brevity in your answer.  0.79. What is the ratio of the Revenue generated (in %) of Sweden in 2006 to that in 2010?
Provide a succinct answer. 0.87. What is the ratio of the Revenue generated (in %) in Low & middle income in 2006 to that in 2011?
Offer a very short reply. 1.13. What is the ratio of the Revenue generated (in %) of Sub-Saharan Africa (all income levels) in 2006 to that in 2011?
Your answer should be very brief. 1.01. What is the ratio of the Revenue generated (in %) in Russian Federation in 2006 to that in 2011?
Make the answer very short. 0.73. What is the ratio of the Revenue generated (in %) in Sweden in 2006 to that in 2011?
Keep it short and to the point. 0.85. What is the ratio of the Revenue generated (in %) in Low & middle income in 2007 to that in 2008?
Keep it short and to the point. 1.2. What is the ratio of the Revenue generated (in %) in Sub-Saharan Africa (all income levels) in 2007 to that in 2008?
Your answer should be very brief. 0.95. What is the ratio of the Revenue generated (in %) in Russian Federation in 2007 to that in 2008?
Give a very brief answer. 0.73. What is the ratio of the Revenue generated (in %) of Sweden in 2007 to that in 2008?
Ensure brevity in your answer.  0.92. What is the ratio of the Revenue generated (in %) of Low & middle income in 2007 to that in 2009?
Keep it short and to the point. 1.13. What is the ratio of the Revenue generated (in %) of Sub-Saharan Africa (all income levels) in 2007 to that in 2009?
Your answer should be compact. 0.92. What is the ratio of the Revenue generated (in %) of Russian Federation in 2007 to that in 2009?
Provide a short and direct response. 1.02. What is the ratio of the Revenue generated (in %) of Sweden in 2007 to that in 2009?
Give a very brief answer. 0.95. What is the ratio of the Revenue generated (in %) in Low & middle income in 2007 to that in 2010?
Your answer should be very brief. 1.11. What is the ratio of the Revenue generated (in %) of Sub-Saharan Africa (all income levels) in 2007 to that in 2010?
Your answer should be very brief. 0.95. What is the ratio of the Revenue generated (in %) in Russian Federation in 2007 to that in 2010?
Keep it short and to the point. 0.91. What is the ratio of the Revenue generated (in %) of Low & middle income in 2007 to that in 2011?
Keep it short and to the point. 1.29. What is the ratio of the Revenue generated (in %) in Sub-Saharan Africa (all income levels) in 2007 to that in 2011?
Provide a short and direct response. 0.98. What is the ratio of the Revenue generated (in %) in Russian Federation in 2007 to that in 2011?
Give a very brief answer. 0.83. What is the ratio of the Revenue generated (in %) of Sweden in 2007 to that in 2011?
Keep it short and to the point. 0.97. What is the ratio of the Revenue generated (in %) in Low & middle income in 2008 to that in 2009?
Offer a very short reply. 0.94. What is the ratio of the Revenue generated (in %) of Sub-Saharan Africa (all income levels) in 2008 to that in 2009?
Make the answer very short. 0.96. What is the ratio of the Revenue generated (in %) of Russian Federation in 2008 to that in 2009?
Ensure brevity in your answer.  1.39. What is the ratio of the Revenue generated (in %) of Sweden in 2008 to that in 2009?
Give a very brief answer. 1.04. What is the ratio of the Revenue generated (in %) of Low & middle income in 2008 to that in 2010?
Make the answer very short. 0.93. What is the ratio of the Revenue generated (in %) of Sub-Saharan Africa (all income levels) in 2008 to that in 2010?
Your response must be concise. 1. What is the ratio of the Revenue generated (in %) in Russian Federation in 2008 to that in 2010?
Provide a short and direct response. 1.23. What is the ratio of the Revenue generated (in %) in Sweden in 2008 to that in 2010?
Provide a short and direct response. 1.09. What is the ratio of the Revenue generated (in %) in Low & middle income in 2008 to that in 2011?
Your answer should be compact. 1.08. What is the ratio of the Revenue generated (in %) of Sub-Saharan Africa (all income levels) in 2008 to that in 2011?
Offer a very short reply. 1.02. What is the ratio of the Revenue generated (in %) of Russian Federation in 2008 to that in 2011?
Offer a very short reply. 1.13. What is the ratio of the Revenue generated (in %) of Sweden in 2008 to that in 2011?
Keep it short and to the point. 1.06. What is the ratio of the Revenue generated (in %) of Low & middle income in 2009 to that in 2010?
Make the answer very short. 0.98. What is the ratio of the Revenue generated (in %) of Sub-Saharan Africa (all income levels) in 2009 to that in 2010?
Your response must be concise. 1.04. What is the ratio of the Revenue generated (in %) of Russian Federation in 2009 to that in 2010?
Ensure brevity in your answer.  0.89. What is the ratio of the Revenue generated (in %) in Sweden in 2009 to that in 2010?
Offer a terse response. 1.05. What is the ratio of the Revenue generated (in %) in Low & middle income in 2009 to that in 2011?
Ensure brevity in your answer.  1.15. What is the ratio of the Revenue generated (in %) of Sub-Saharan Africa (all income levels) in 2009 to that in 2011?
Give a very brief answer. 1.06. What is the ratio of the Revenue generated (in %) in Russian Federation in 2009 to that in 2011?
Your answer should be very brief. 0.82. What is the ratio of the Revenue generated (in %) of Sweden in 2009 to that in 2011?
Offer a terse response. 1.02. What is the ratio of the Revenue generated (in %) in Low & middle income in 2010 to that in 2011?
Keep it short and to the point. 1.16. What is the ratio of the Revenue generated (in %) of Sub-Saharan Africa (all income levels) in 2010 to that in 2011?
Ensure brevity in your answer.  1.03. What is the ratio of the Revenue generated (in %) of Russian Federation in 2010 to that in 2011?
Provide a short and direct response. 0.92. What is the ratio of the Revenue generated (in %) of Sweden in 2010 to that in 2011?
Give a very brief answer. 0.97. What is the difference between the highest and the second highest Revenue generated (in %) of Low & middle income?
Your answer should be very brief. 2.22. What is the difference between the highest and the second highest Revenue generated (in %) in Sub-Saharan Africa (all income levels)?
Offer a very short reply. 1.91. What is the difference between the highest and the second highest Revenue generated (in %) of Russian Federation?
Your answer should be very brief. 4.42. What is the difference between the highest and the second highest Revenue generated (in %) in Sweden?
Offer a very short reply. 0.39. What is the difference between the highest and the lowest Revenue generated (in %) of Low & middle income?
Provide a succinct answer. 5.07. What is the difference between the highest and the lowest Revenue generated (in %) of Sub-Saharan Africa (all income levels)?
Provide a succinct answer. 4.22. What is the difference between the highest and the lowest Revenue generated (in %) of Russian Federation?
Offer a terse response. 13.64. What is the difference between the highest and the lowest Revenue generated (in %) in Sweden?
Make the answer very short. 2.24. 